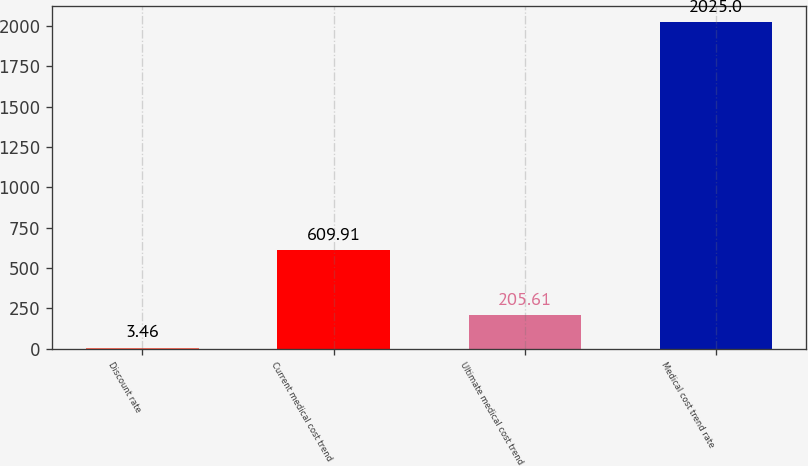<chart> <loc_0><loc_0><loc_500><loc_500><bar_chart><fcel>Discount rate<fcel>Current medical cost trend<fcel>Ultimate medical cost trend<fcel>Medical cost trend rate<nl><fcel>3.46<fcel>609.91<fcel>205.61<fcel>2025<nl></chart> 